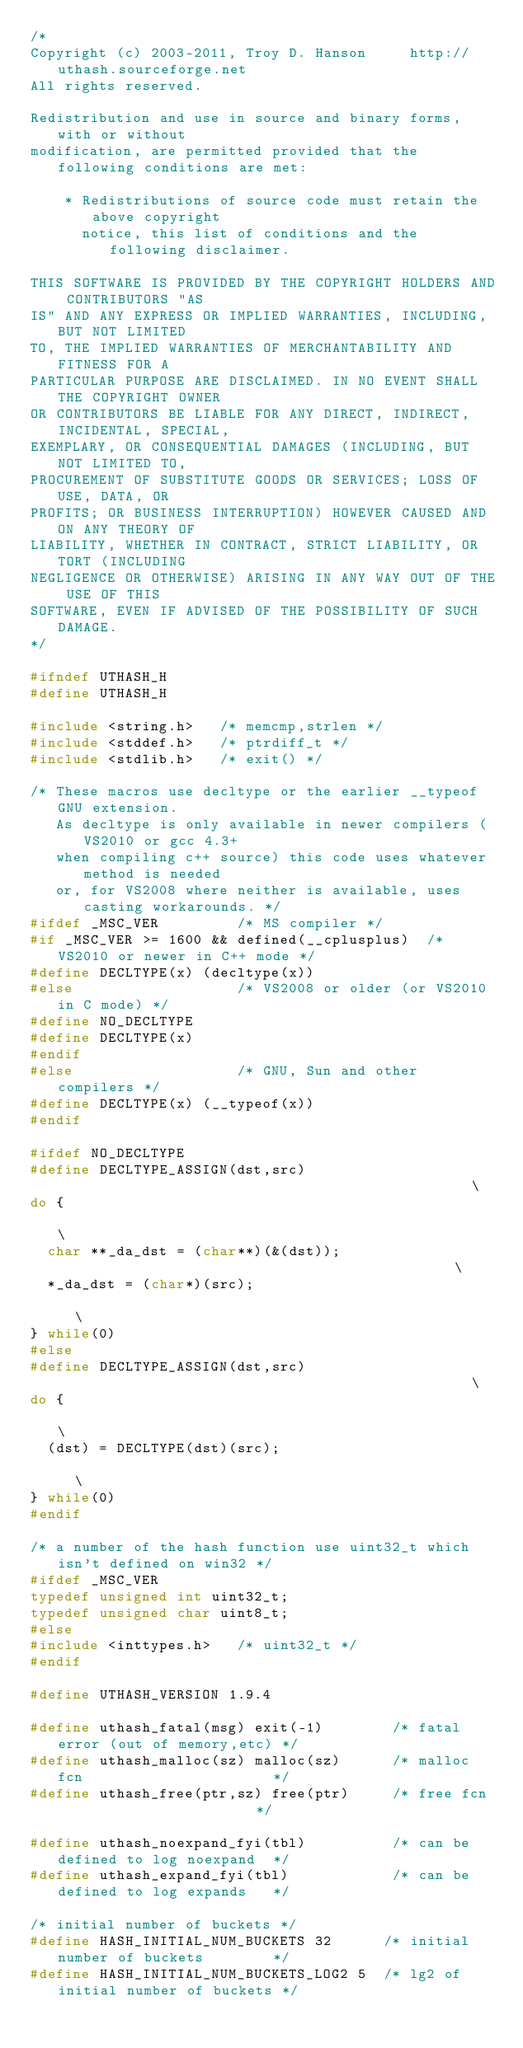<code> <loc_0><loc_0><loc_500><loc_500><_C_>/*
Copyright (c) 2003-2011, Troy D. Hanson     http://uthash.sourceforge.net
All rights reserved.

Redistribution and use in source and binary forms, with or without
modification, are permitted provided that the following conditions are met:

    * Redistributions of source code must retain the above copyright
      notice, this list of conditions and the following disclaimer.

THIS SOFTWARE IS PROVIDED BY THE COPYRIGHT HOLDERS AND CONTRIBUTORS "AS
IS" AND ANY EXPRESS OR IMPLIED WARRANTIES, INCLUDING, BUT NOT LIMITED
TO, THE IMPLIED WARRANTIES OF MERCHANTABILITY AND FITNESS FOR A
PARTICULAR PURPOSE ARE DISCLAIMED. IN NO EVENT SHALL THE COPYRIGHT OWNER
OR CONTRIBUTORS BE LIABLE FOR ANY DIRECT, INDIRECT, INCIDENTAL, SPECIAL,
EXEMPLARY, OR CONSEQUENTIAL DAMAGES (INCLUDING, BUT NOT LIMITED TO,
PROCUREMENT OF SUBSTITUTE GOODS OR SERVICES; LOSS OF USE, DATA, OR
PROFITS; OR BUSINESS INTERRUPTION) HOWEVER CAUSED AND ON ANY THEORY OF
LIABILITY, WHETHER IN CONTRACT, STRICT LIABILITY, OR TORT (INCLUDING
NEGLIGENCE OR OTHERWISE) ARISING IN ANY WAY OUT OF THE USE OF THIS
SOFTWARE, EVEN IF ADVISED OF THE POSSIBILITY OF SUCH DAMAGE.
*/

#ifndef UTHASH_H
#define UTHASH_H 

#include <string.h>   /* memcmp,strlen */
#include <stddef.h>   /* ptrdiff_t */
#include <stdlib.h>   /* exit() */

/* These macros use decltype or the earlier __typeof GNU extension.
   As decltype is only available in newer compilers (VS2010 or gcc 4.3+
   when compiling c++ source) this code uses whatever method is needed
   or, for VS2008 where neither is available, uses casting workarounds. */
#ifdef _MSC_VER         /* MS compiler */
#if _MSC_VER >= 1600 && defined(__cplusplus)  /* VS2010 or newer in C++ mode */
#define DECLTYPE(x) (decltype(x))
#else                   /* VS2008 or older (or VS2010 in C mode) */
#define NO_DECLTYPE
#define DECLTYPE(x)
#endif
#else                   /* GNU, Sun and other compilers */
#define DECLTYPE(x) (__typeof(x))
#endif

#ifdef NO_DECLTYPE
#define DECLTYPE_ASSIGN(dst,src)                                                 \
do {                                                                             \
  char **_da_dst = (char**)(&(dst));                                             \
  *_da_dst = (char*)(src);                                                       \
} while(0)
#else 
#define DECLTYPE_ASSIGN(dst,src)                                                 \
do {                                                                             \
  (dst) = DECLTYPE(dst)(src);                                                    \
} while(0)
#endif

/* a number of the hash function use uint32_t which isn't defined on win32 */
#ifdef _MSC_VER
typedef unsigned int uint32_t;
typedef unsigned char uint8_t;
#else
#include <inttypes.h>   /* uint32_t */
#endif

#define UTHASH_VERSION 1.9.4

#define uthash_fatal(msg) exit(-1)        /* fatal error (out of memory,etc) */
#define uthash_malloc(sz) malloc(sz)      /* malloc fcn                      */
#define uthash_free(ptr,sz) free(ptr)     /* free fcn                        */

#define uthash_noexpand_fyi(tbl)          /* can be defined to log noexpand  */
#define uthash_expand_fyi(tbl)            /* can be defined to log expands   */

/* initial number of buckets */
#define HASH_INITIAL_NUM_BUCKETS 32      /* initial number of buckets        */
#define HASH_INITIAL_NUM_BUCKETS_LOG2 5  /* lg2 of initial number of buckets */</code> 